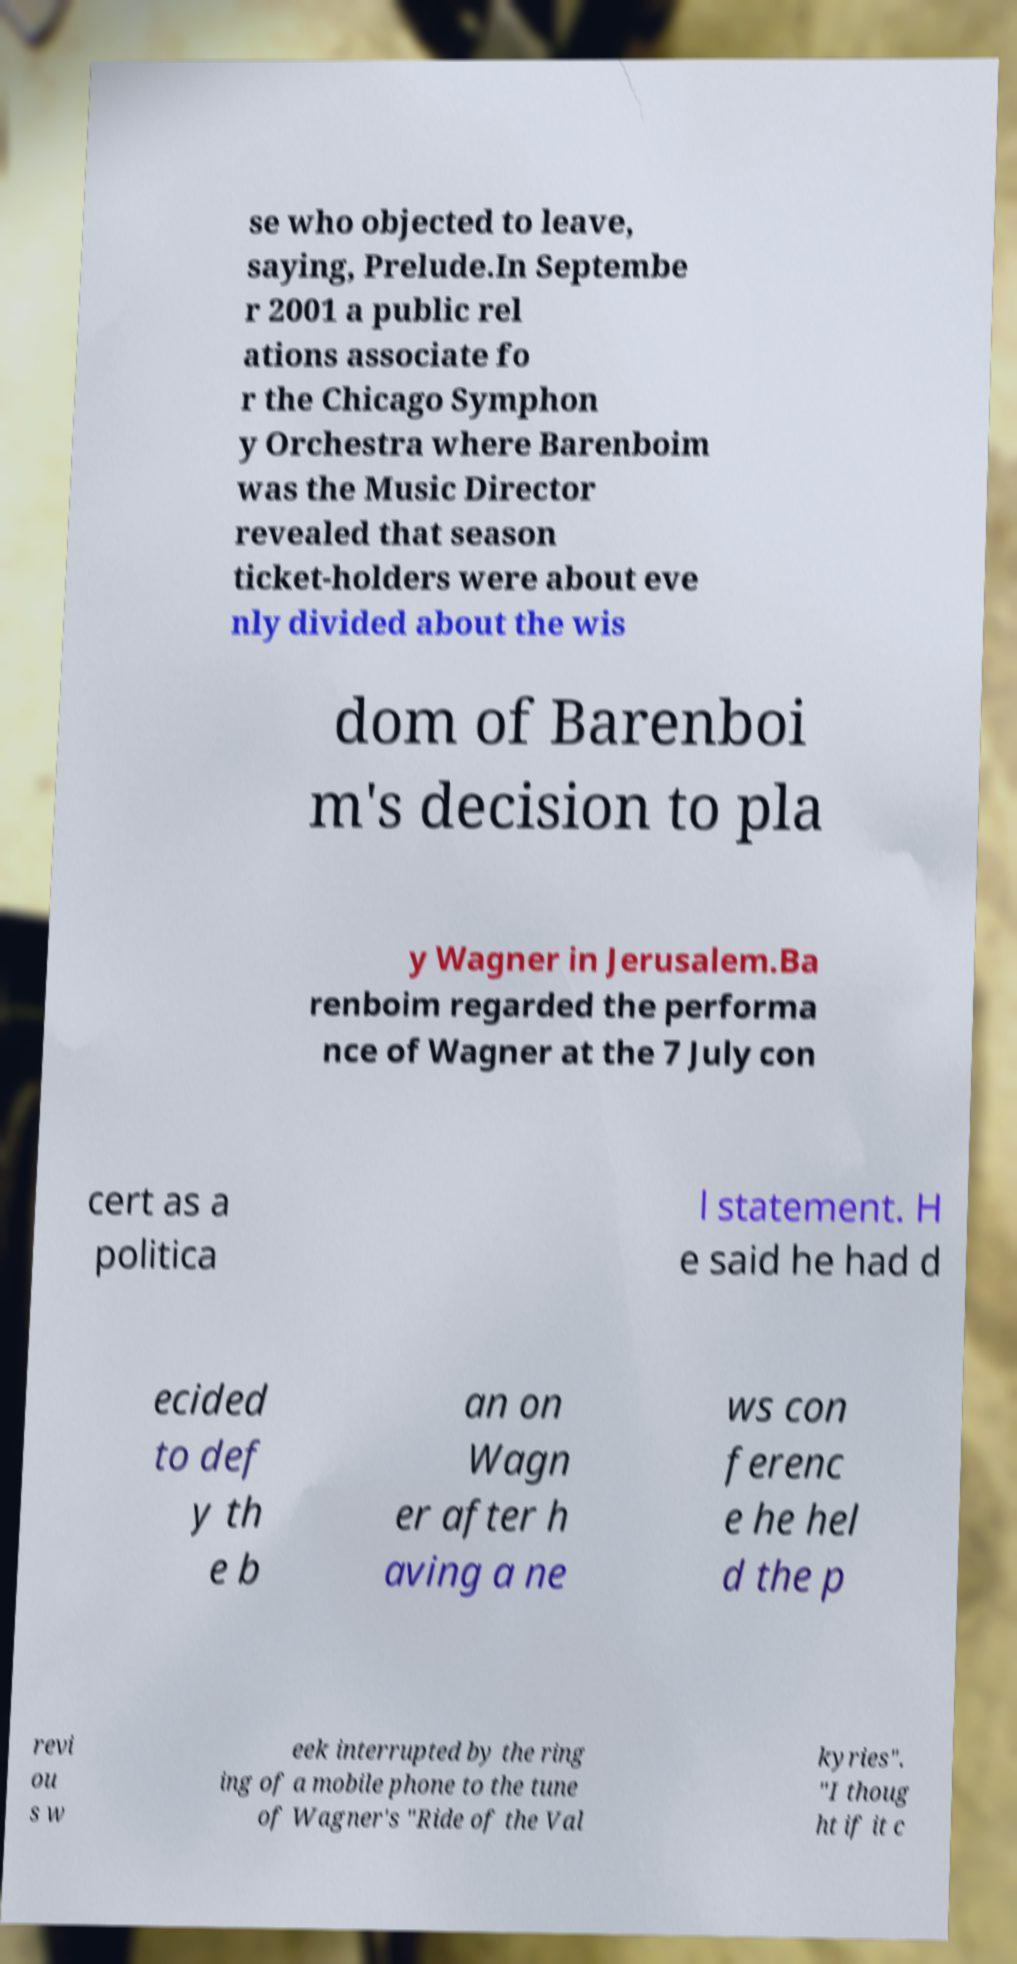What messages or text are displayed in this image? I need them in a readable, typed format. se who objected to leave, saying, Prelude.In Septembe r 2001 a public rel ations associate fo r the Chicago Symphon y Orchestra where Barenboim was the Music Director revealed that season ticket-holders were about eve nly divided about the wis dom of Barenboi m's decision to pla y Wagner in Jerusalem.Ba renboim regarded the performa nce of Wagner at the 7 July con cert as a politica l statement. H e said he had d ecided to def y th e b an on Wagn er after h aving a ne ws con ferenc e he hel d the p revi ou s w eek interrupted by the ring ing of a mobile phone to the tune of Wagner's "Ride of the Val kyries". "I thoug ht if it c 